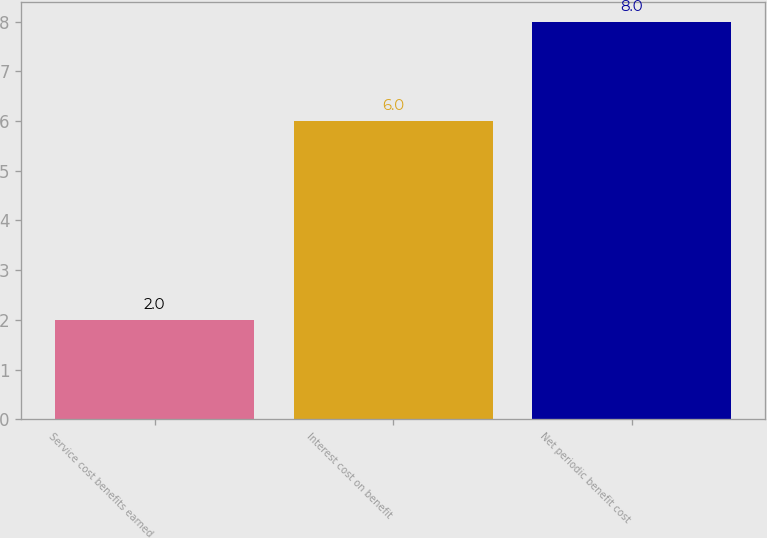Convert chart to OTSL. <chart><loc_0><loc_0><loc_500><loc_500><bar_chart><fcel>Service cost benefits earned<fcel>Interest cost on benefit<fcel>Net periodic benefit cost<nl><fcel>2<fcel>6<fcel>8<nl></chart> 